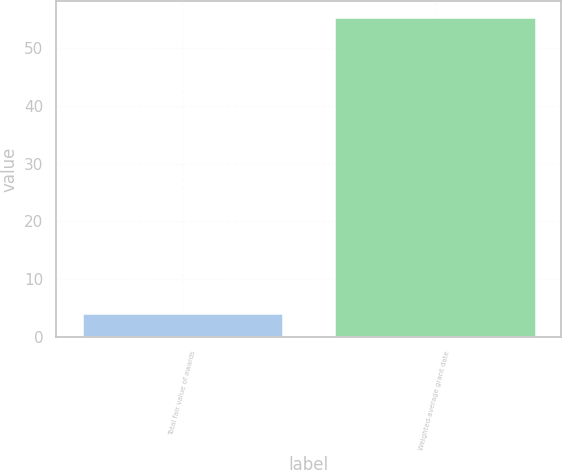Convert chart to OTSL. <chart><loc_0><loc_0><loc_500><loc_500><bar_chart><fcel>Total fair value of awards<fcel>Weighted-average grant date<nl><fcel>4.2<fcel>55.43<nl></chart> 